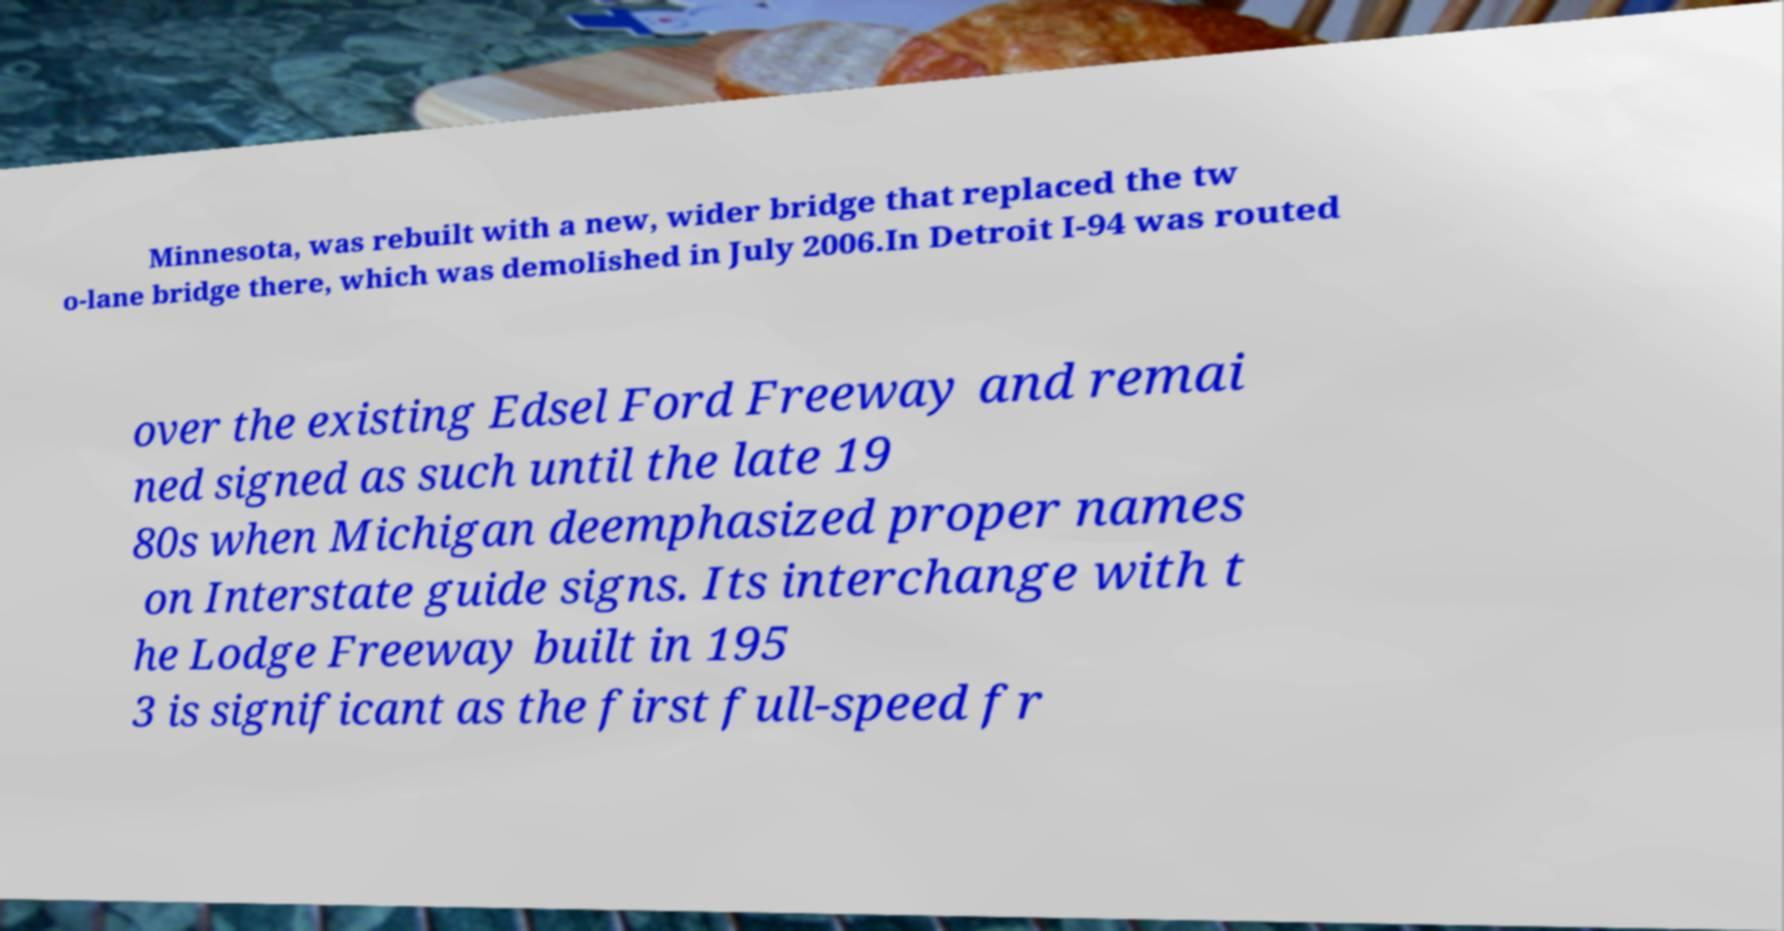Can you read and provide the text displayed in the image?This photo seems to have some interesting text. Can you extract and type it out for me? Minnesota, was rebuilt with a new, wider bridge that replaced the tw o-lane bridge there, which was demolished in July 2006.In Detroit I-94 was routed over the existing Edsel Ford Freeway and remai ned signed as such until the late 19 80s when Michigan deemphasized proper names on Interstate guide signs. Its interchange with t he Lodge Freeway built in 195 3 is significant as the first full-speed fr 